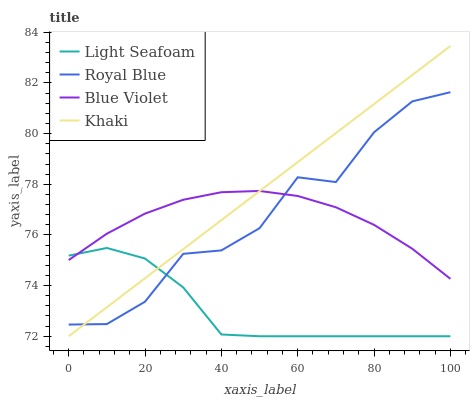Does Light Seafoam have the minimum area under the curve?
Answer yes or no. Yes. Does Khaki have the maximum area under the curve?
Answer yes or no. Yes. Does Khaki have the minimum area under the curve?
Answer yes or no. No. Does Light Seafoam have the maximum area under the curve?
Answer yes or no. No. Is Khaki the smoothest?
Answer yes or no. Yes. Is Royal Blue the roughest?
Answer yes or no. Yes. Is Light Seafoam the smoothest?
Answer yes or no. No. Is Light Seafoam the roughest?
Answer yes or no. No. Does Light Seafoam have the lowest value?
Answer yes or no. Yes. Does Blue Violet have the lowest value?
Answer yes or no. No. Does Khaki have the highest value?
Answer yes or no. Yes. Does Light Seafoam have the highest value?
Answer yes or no. No. Does Light Seafoam intersect Khaki?
Answer yes or no. Yes. Is Light Seafoam less than Khaki?
Answer yes or no. No. Is Light Seafoam greater than Khaki?
Answer yes or no. No. 